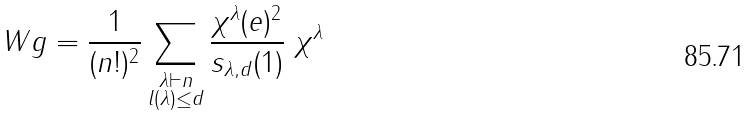<formula> <loc_0><loc_0><loc_500><loc_500>\ W g = \frac { 1 } { ( n ! ) ^ { 2 } } \sum _ { \substack { \lambda \vdash n \\ l ( \lambda ) \leq d } } \frac { \chi ^ { \lambda } ( e ) ^ { 2 } } { s _ { \lambda , d } ( 1 ) } \ \chi ^ { \lambda }</formula> 